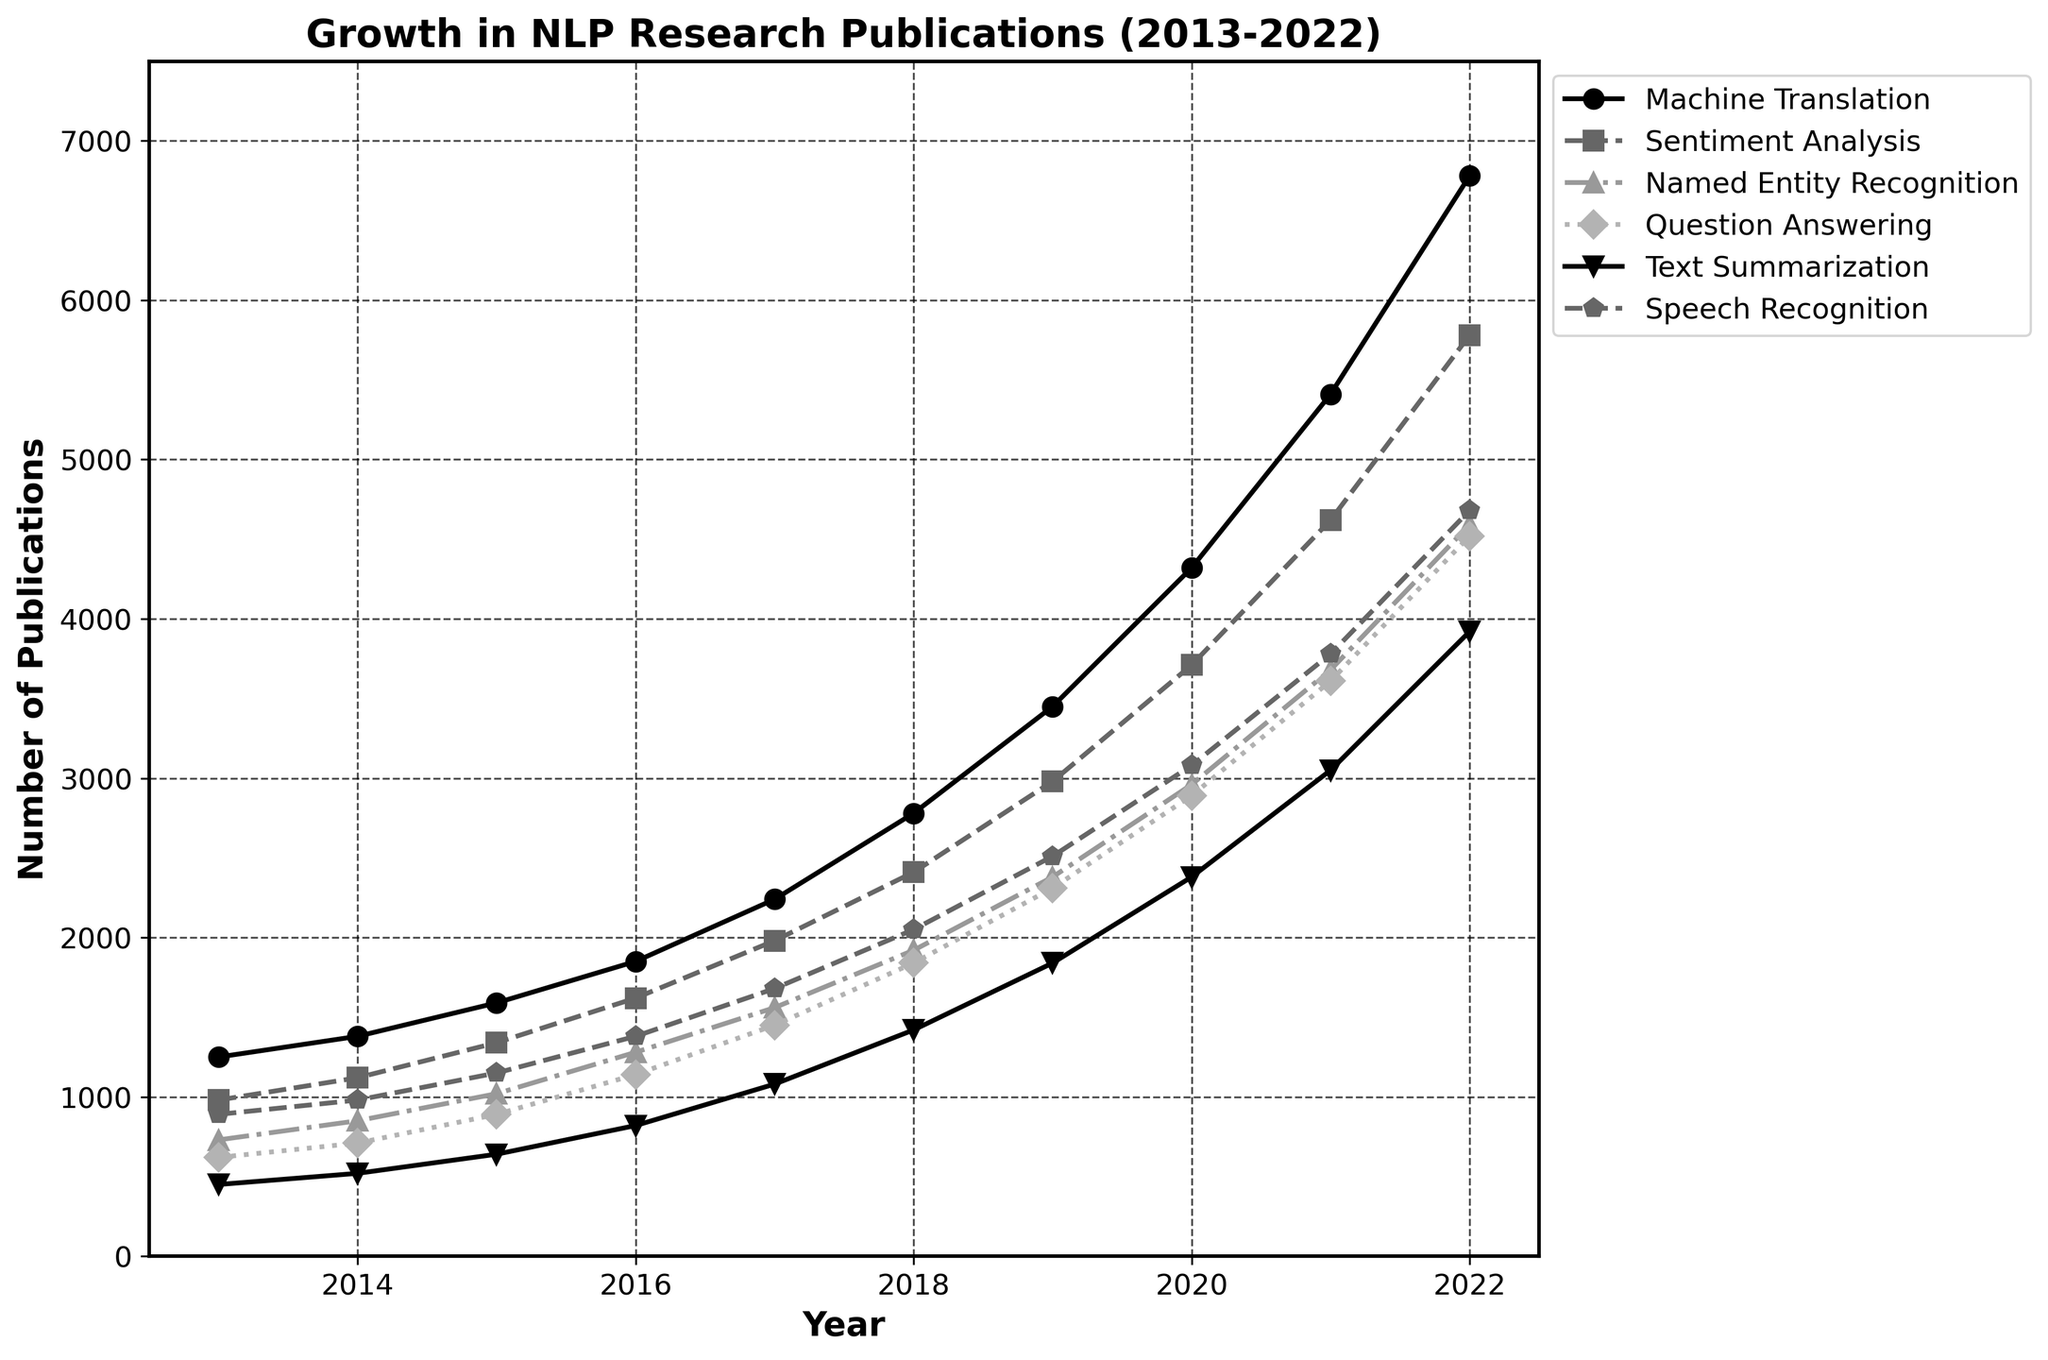How many total publications were there in 2017 across all subfields? Sum the number of publications in each subfield for the year 2017: Machine Translation (2240) + Sentiment Analysis (1980) + Named Entity Recognition (1560) + Question Answering (1450) + Text Summarization (1080) + Speech Recognition (1680). The total is 2240 + 1980 + 1560 + 1450 + 1080 + 1680 = 9990
Answer: 9990 Which subfield had the largest growth in publications from 2013 to 2022? Calculate the difference in the number of publications between 2022 and 2013 for each subfield: Machine Translation (6780-1250), Sentiment Analysis (5780-980), Named Entity Recognition (4590-730), Question Answering (4520-620), Text Summarization (3920-450), Speech Recognition (4680-890). Compare the differences: Machine Translation (5530), Sentiment Analysis (4800), Named Entity Recognition (3860), Question Answering (3900), Text Summarization (3470), Speech Recognition (3790). The largest growth is in Machine Translation
Answer: Machine Translation What is the average number of publications in the Text Summarization subfield for the years shown? Sum the number of publications in the Text Summarization subfield for each year and divide by the number of years: (450 + 520 + 640 + 820 + 1080 + 1420 + 1840 + 2380 + 3050 + 3920) / 10. The total is 14120. The average is 14120 / 10 = 1412
Answer: 1412 Which year saw a higher number of publications in Speech Recognition: 2016 or 2018? Compare the number of publications in the Speech Recognition subfield for the years 2016 (1380) and 2018 (2050). Since 2050 > 1380, 2018 saw more publications in Speech Recognition
Answer: 2018 In which subfield did the number of publications first exceed 3000? Identify the year in which each subfield first exceeded 3000 publications: Machine Translation in 2019 (3450), Sentiment Analysis in 2020 (3710), Named Entity Recognition did not exceed 3000, Question Answering in 2020 (2890), Text Summarization did not exceed 3000, Speech Recognition in 2020 (3080). The earliest was Machine Translation in 2019
Answer: Machine Translation in 2019 Which subfield had the slowest growth rate in publications over the decade? Calculate the growth rate for each subfield: Machine Translation (6780-1250), Sentiment Analysis (5780-980), Named Entity Recognition (4590-730), Question Answering (4520-620), Text Summarization (3920-450), Speech Recognition (4680-890). Compare the differences and identify the smallest: Text Summarization (3470) has the smallest growth rate
Answer: Text Summarization How did the number of publications in Question Answering compare to Named Entity Recognition in 2021? Compare the number of publications in Question Answering (3610) and Named Entity Recognition (3680) in 2021. Since 3610 < 3680, Named Entity Recognition had more publications
Answer: Named Entity Recognition Which subfield consistently increased in the number of publications every year? Examine the data for each subfield to determine if the number of publications increased every year from 2013 to 2022. Machine Translation, Sentiment Analysis, and Question Answering all show consistent yearly increases. Select any one of these as an example
Answer: Machine Translation 